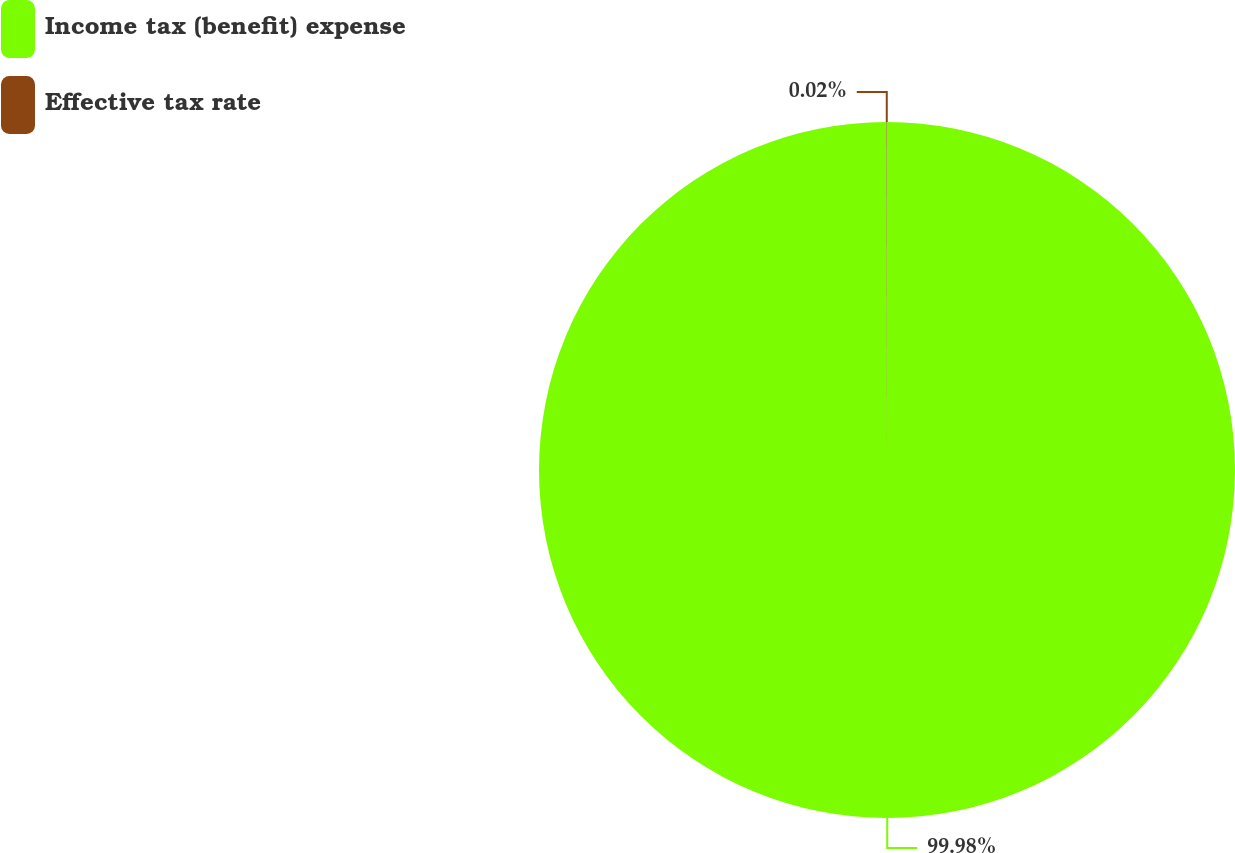Convert chart to OTSL. <chart><loc_0><loc_0><loc_500><loc_500><pie_chart><fcel>Income tax (benefit) expense<fcel>Effective tax rate<nl><fcel>99.98%<fcel>0.02%<nl></chart> 